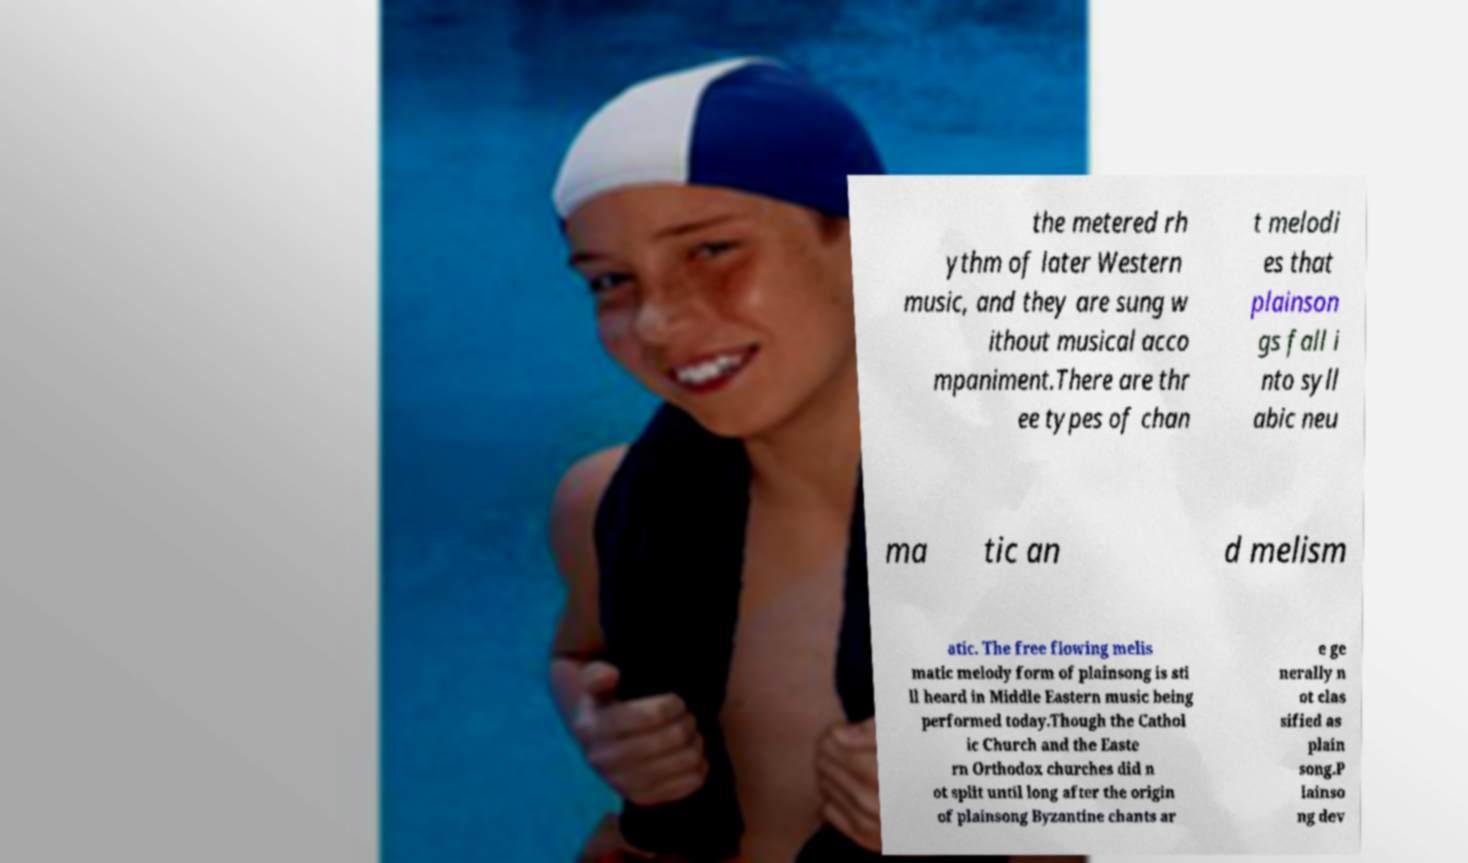Could you assist in decoding the text presented in this image and type it out clearly? the metered rh ythm of later Western music, and they are sung w ithout musical acco mpaniment.There are thr ee types of chan t melodi es that plainson gs fall i nto syll abic neu ma tic an d melism atic. The free flowing melis matic melody form of plainsong is sti ll heard in Middle Eastern music being performed today.Though the Cathol ic Church and the Easte rn Orthodox churches did n ot split until long after the origin of plainsong Byzantine chants ar e ge nerally n ot clas sified as plain song.P lainso ng dev 